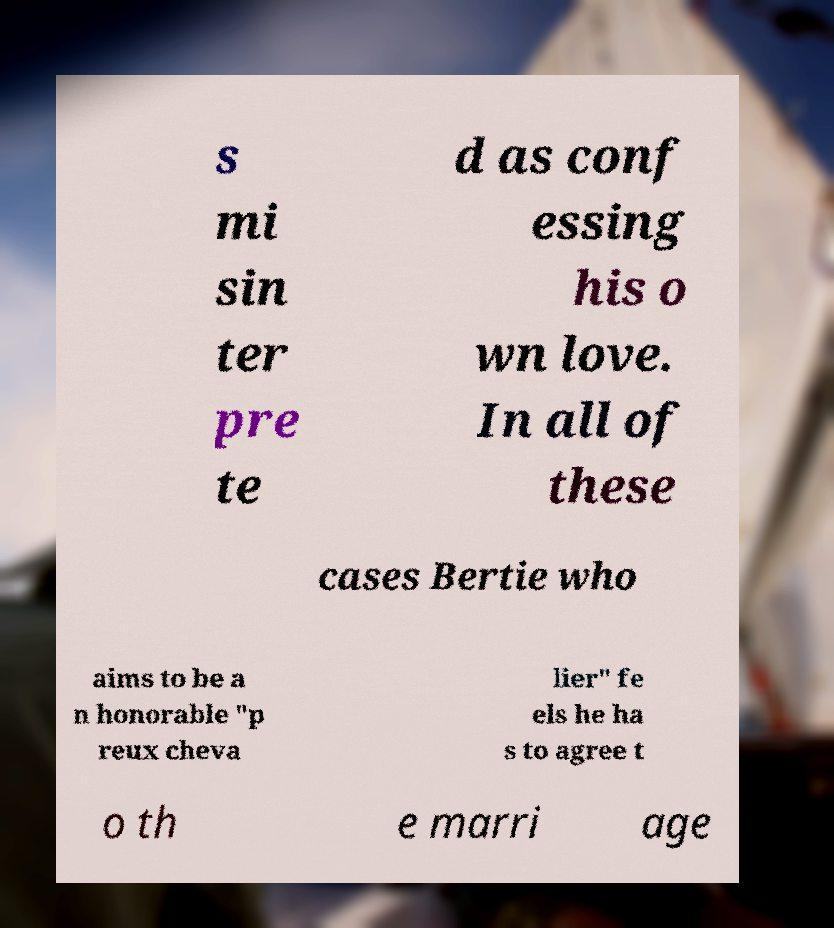Please read and relay the text visible in this image. What does it say? s mi sin ter pre te d as conf essing his o wn love. In all of these cases Bertie who aims to be a n honorable "p reux cheva lier" fe els he ha s to agree t o th e marri age 